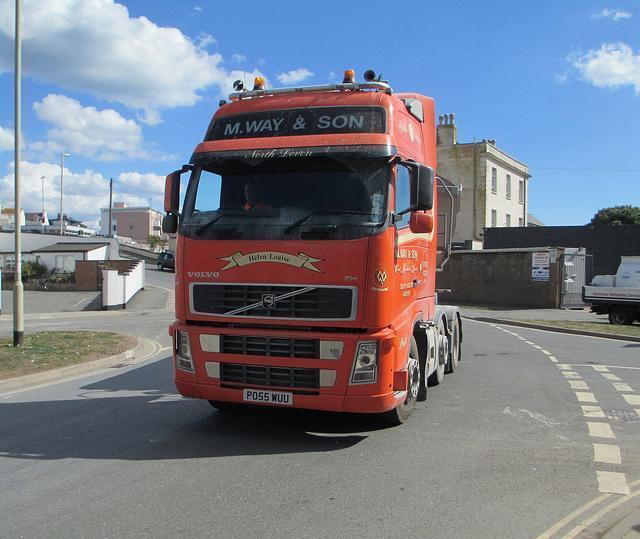How many wheels on the truck?
Give a very brief answer. 6. How many trucks are in the picture?
Give a very brief answer. 1. How many trucks are in the photo?
Give a very brief answer. 2. How many white plastic forks are there?
Give a very brief answer. 0. 